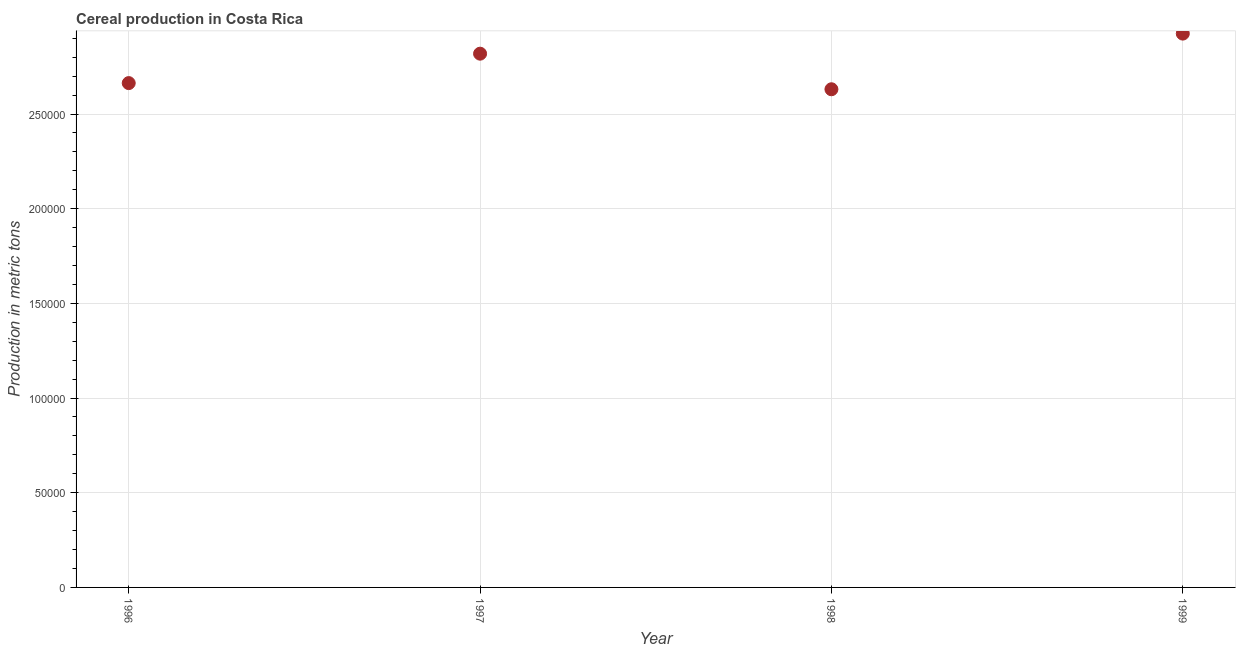What is the cereal production in 1996?
Your answer should be compact. 2.66e+05. Across all years, what is the maximum cereal production?
Offer a very short reply. 2.92e+05. Across all years, what is the minimum cereal production?
Provide a short and direct response. 2.63e+05. In which year was the cereal production maximum?
Make the answer very short. 1999. What is the sum of the cereal production?
Provide a succinct answer. 1.10e+06. What is the difference between the cereal production in 1996 and 1999?
Offer a very short reply. -2.61e+04. What is the average cereal production per year?
Your answer should be very brief. 2.76e+05. What is the median cereal production?
Ensure brevity in your answer.  2.74e+05. Do a majority of the years between 1999 and 1997 (inclusive) have cereal production greater than 150000 metric tons?
Keep it short and to the point. No. What is the ratio of the cereal production in 1996 to that in 1999?
Give a very brief answer. 0.91. Is the difference between the cereal production in 1996 and 1999 greater than the difference between any two years?
Your response must be concise. No. What is the difference between the highest and the second highest cereal production?
Offer a terse response. 1.06e+04. What is the difference between the highest and the lowest cereal production?
Provide a succinct answer. 2.94e+04. Does the cereal production monotonically increase over the years?
Keep it short and to the point. No. How many dotlines are there?
Ensure brevity in your answer.  1. Does the graph contain any zero values?
Give a very brief answer. No. Does the graph contain grids?
Provide a succinct answer. Yes. What is the title of the graph?
Your answer should be compact. Cereal production in Costa Rica. What is the label or title of the X-axis?
Keep it short and to the point. Year. What is the label or title of the Y-axis?
Offer a very short reply. Production in metric tons. What is the Production in metric tons in 1996?
Your answer should be very brief. 2.66e+05. What is the Production in metric tons in 1997?
Provide a succinct answer. 2.82e+05. What is the Production in metric tons in 1998?
Your answer should be compact. 2.63e+05. What is the Production in metric tons in 1999?
Your response must be concise. 2.92e+05. What is the difference between the Production in metric tons in 1996 and 1997?
Your response must be concise. -1.55e+04. What is the difference between the Production in metric tons in 1996 and 1998?
Your response must be concise. 3254. What is the difference between the Production in metric tons in 1996 and 1999?
Ensure brevity in your answer.  -2.61e+04. What is the difference between the Production in metric tons in 1997 and 1998?
Your response must be concise. 1.88e+04. What is the difference between the Production in metric tons in 1997 and 1999?
Give a very brief answer. -1.06e+04. What is the difference between the Production in metric tons in 1998 and 1999?
Your response must be concise. -2.94e+04. What is the ratio of the Production in metric tons in 1996 to that in 1997?
Your response must be concise. 0.94. What is the ratio of the Production in metric tons in 1996 to that in 1998?
Give a very brief answer. 1.01. What is the ratio of the Production in metric tons in 1996 to that in 1999?
Offer a very short reply. 0.91. What is the ratio of the Production in metric tons in 1997 to that in 1998?
Give a very brief answer. 1.07. What is the ratio of the Production in metric tons in 1998 to that in 1999?
Keep it short and to the point. 0.9. 